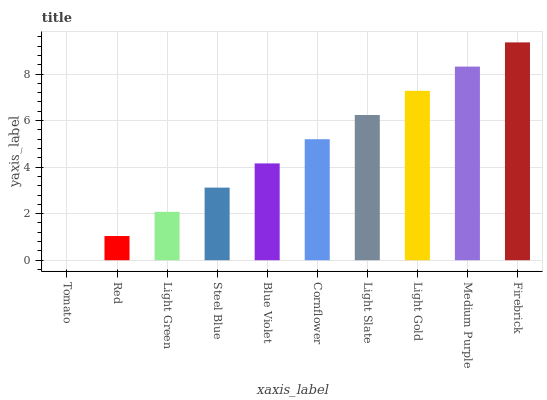Is Tomato the minimum?
Answer yes or no. Yes. Is Firebrick the maximum?
Answer yes or no. Yes. Is Red the minimum?
Answer yes or no. No. Is Red the maximum?
Answer yes or no. No. Is Red greater than Tomato?
Answer yes or no. Yes. Is Tomato less than Red?
Answer yes or no. Yes. Is Tomato greater than Red?
Answer yes or no. No. Is Red less than Tomato?
Answer yes or no. No. Is Cornflower the high median?
Answer yes or no. Yes. Is Blue Violet the low median?
Answer yes or no. Yes. Is Firebrick the high median?
Answer yes or no. No. Is Cornflower the low median?
Answer yes or no. No. 